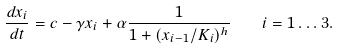Convert formula to latex. <formula><loc_0><loc_0><loc_500><loc_500>\frac { d x _ { i } } { d t } = c - \gamma x _ { i } + \alpha \frac { 1 } { 1 + ( x _ { i - 1 } / K _ { i } ) ^ { h } } \quad i = 1 \dots 3 .</formula> 